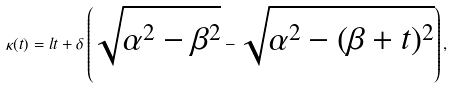<formula> <loc_0><loc_0><loc_500><loc_500>\kappa ( t ) = l t + \delta \left ( \sqrt { \alpha ^ { 2 } - \beta ^ { 2 } } - \sqrt { \alpha ^ { 2 } - ( \beta + t ) ^ { 2 } } \right ) ,</formula> 